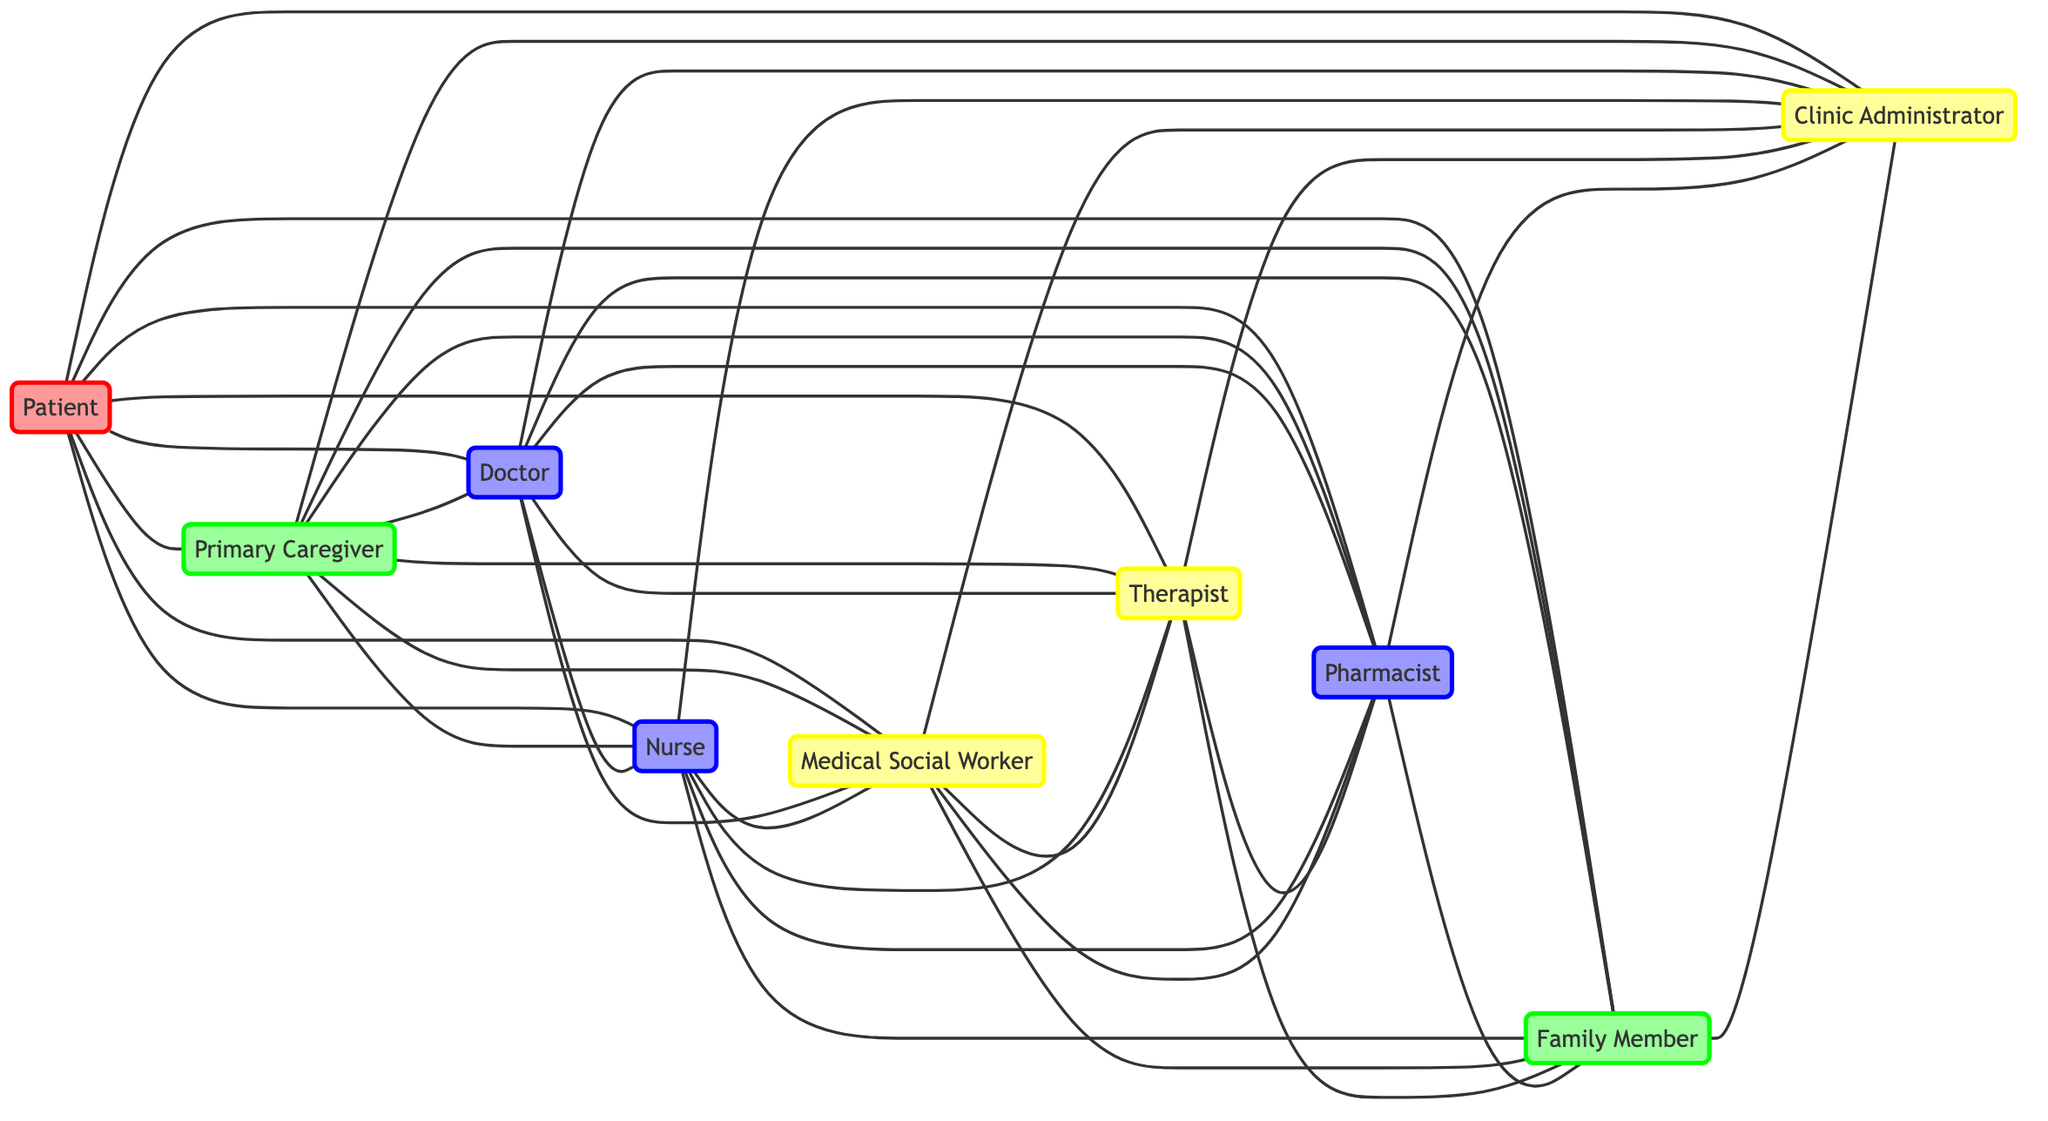What is the total number of nodes in the diagram? By counting each unique entity listed under "nodes," we identify 9 distinct nodes in the diagram.
Answer: 9 Which caregiver is directly connected to the patient? The direct connections from the patient node indicate the following caregivers: primary caregiver, family member.
Answer: Primary Caregiver, Family Member How many connections does the doctor have? By examining the edges from the doctor node, we see it has connections to nurse, medical social worker, therapist, pharmacist, family member, and clinic administrator, totaling 6 connections.
Answer: 6 Who is connected to the nurse? The nurse has direct connections to medical social worker, therapist, pharmacist, family member, clinic administrator, and doctor, indicating multiple relationships.
Answer: Medical Social Worker, Therapist, Pharmacist, Family Member, Clinic Administrator, Doctor How many edges connect the primary caregiver to other nodes? The primary caregiver connects to the doctor, nurse, medical social worker, therapist, pharmacist, family member, and clinic administrator, leading to 7 edges.
Answer: 7 Which role has the most connections in the diagram? Noticing that medical social worker connects to therapist, pharmacist, family member, and clinic administrator, as well as links with the patient and primary caregiver, it appears to have the most connections.
Answer: Medical Social Worker What is the relationship between the therapist and the pharmacist? The therapist and pharmacist are connected directly, indicating a collaborative relationship or communication line between these two roles.
Answer: Connected What is the role that is only connected to the clinic administrator? By reviewing the connections from the clinic administrator, it shows interactions with family member only, indicating a specific line of communication.
Answer: Family Member 